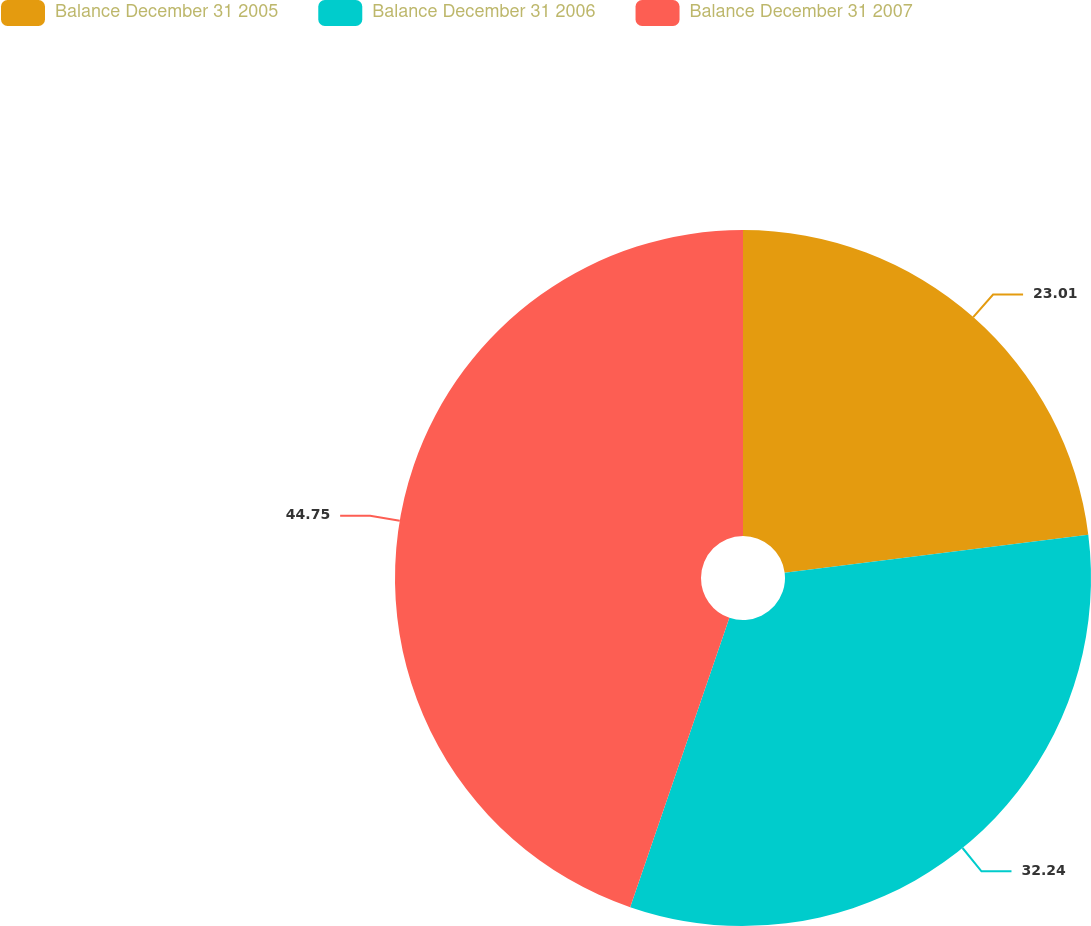<chart> <loc_0><loc_0><loc_500><loc_500><pie_chart><fcel>Balance December 31 2005<fcel>Balance December 31 2006<fcel>Balance December 31 2007<nl><fcel>23.01%<fcel>32.24%<fcel>44.74%<nl></chart> 